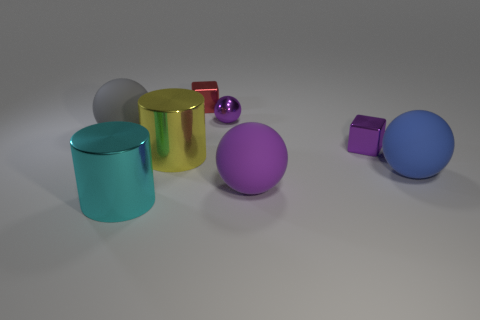What number of things are red metal things that are behind the big purple matte ball or red shiny things? In the image, there are two red items in total: one red glossy sphere located towards the front and a smaller red cube positioned at the back, slightly to the right. Separately, behind the large purple matte ball, there are no red metal objects. 